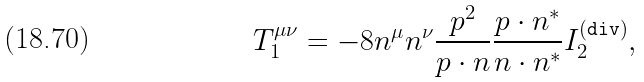<formula> <loc_0><loc_0><loc_500><loc_500>T _ { 1 } ^ { \mu \nu } = - 8 n ^ { \mu } n ^ { \nu } \frac { p ^ { 2 } } { p \cdot n } \frac { p \cdot n ^ { * } } { n \cdot n ^ { * } } I _ { 2 } ^ { ( \tt d i v ) } ,</formula> 